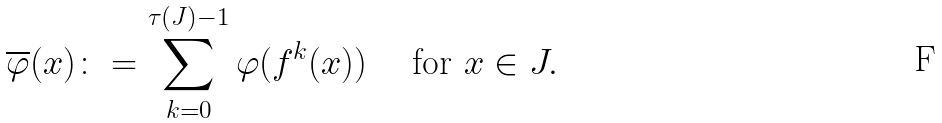Convert formula to latex. <formula><loc_0><loc_0><loc_500><loc_500>\overline { \varphi } ( x ) \colon = \sum _ { k = 0 } ^ { \tau ( J ) - 1 } \varphi ( f ^ { k } ( x ) ) \quad \text { for } x \in J .</formula> 